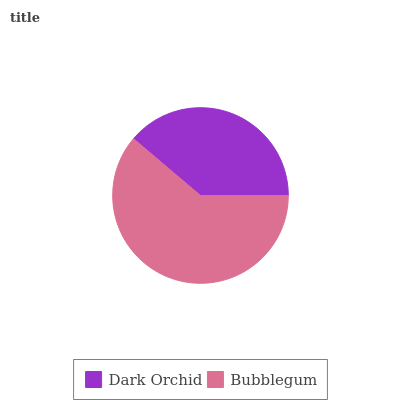Is Dark Orchid the minimum?
Answer yes or no. Yes. Is Bubblegum the maximum?
Answer yes or no. Yes. Is Bubblegum the minimum?
Answer yes or no. No. Is Bubblegum greater than Dark Orchid?
Answer yes or no. Yes. Is Dark Orchid less than Bubblegum?
Answer yes or no. Yes. Is Dark Orchid greater than Bubblegum?
Answer yes or no. No. Is Bubblegum less than Dark Orchid?
Answer yes or no. No. Is Bubblegum the high median?
Answer yes or no. Yes. Is Dark Orchid the low median?
Answer yes or no. Yes. Is Dark Orchid the high median?
Answer yes or no. No. Is Bubblegum the low median?
Answer yes or no. No. 